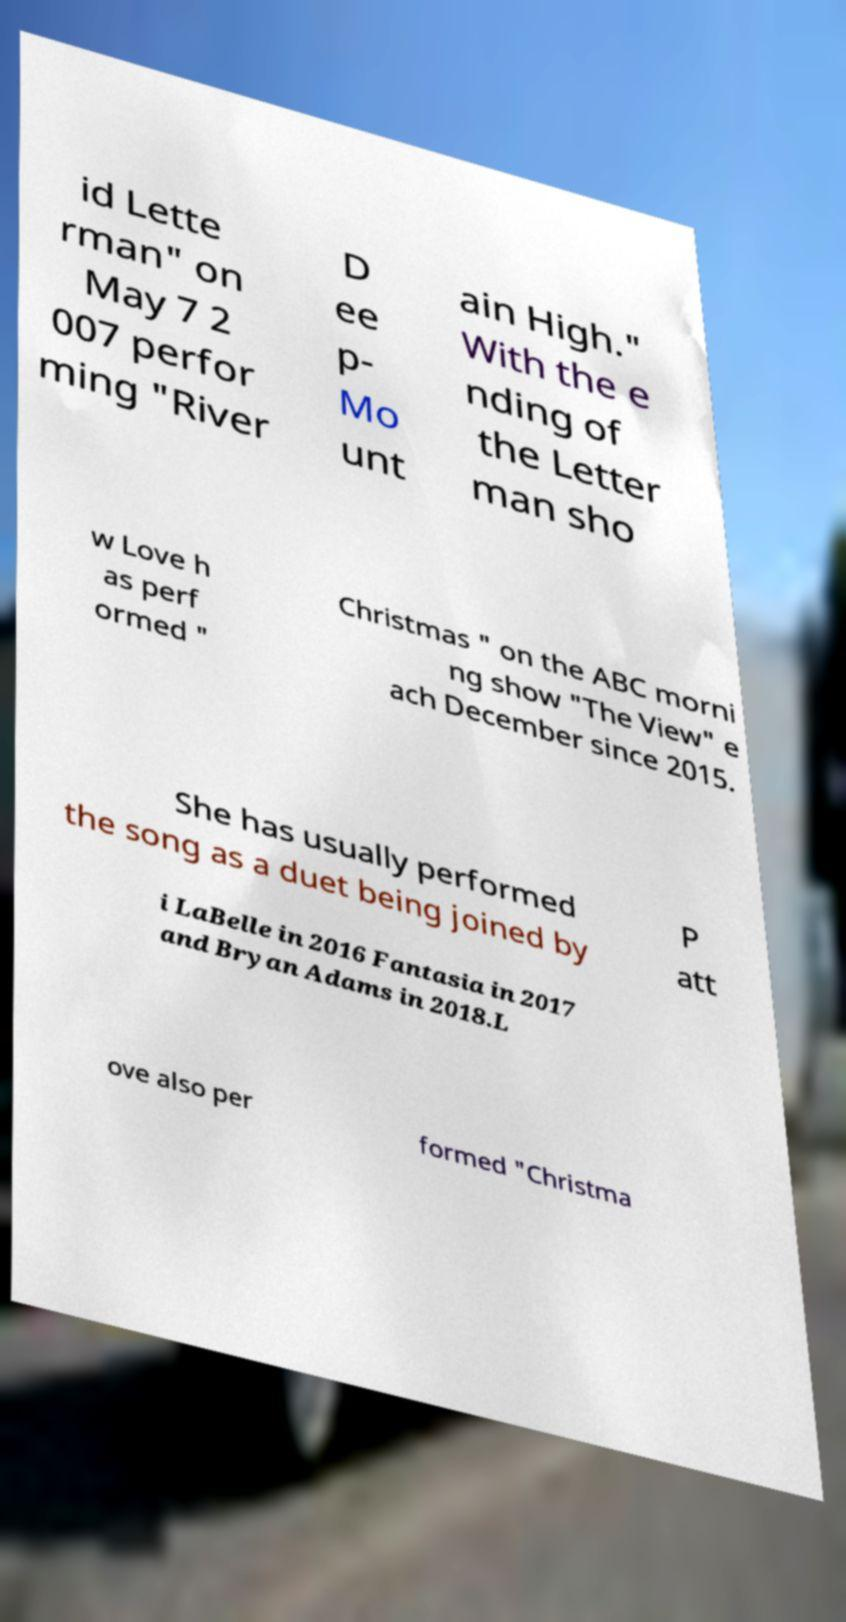Could you extract and type out the text from this image? id Lette rman" on May 7 2 007 perfor ming "River D ee p- Mo unt ain High." With the e nding of the Letter man sho w Love h as perf ormed " Christmas " on the ABC morni ng show "The View" e ach December since 2015. She has usually performed the song as a duet being joined by P att i LaBelle in 2016 Fantasia in 2017 and Bryan Adams in 2018.L ove also per formed "Christma 